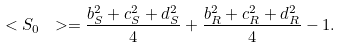Convert formula to latex. <formula><loc_0><loc_0><loc_500><loc_500>\ < S _ { 0 } \ > = \frac { b _ { S } ^ { 2 } + c _ { S } ^ { 2 } + d _ { S } ^ { 2 } } { 4 } + \frac { b _ { R } ^ { 2 } + c _ { R } ^ { 2 } + d _ { R } ^ { 2 } } { 4 } - 1 .</formula> 